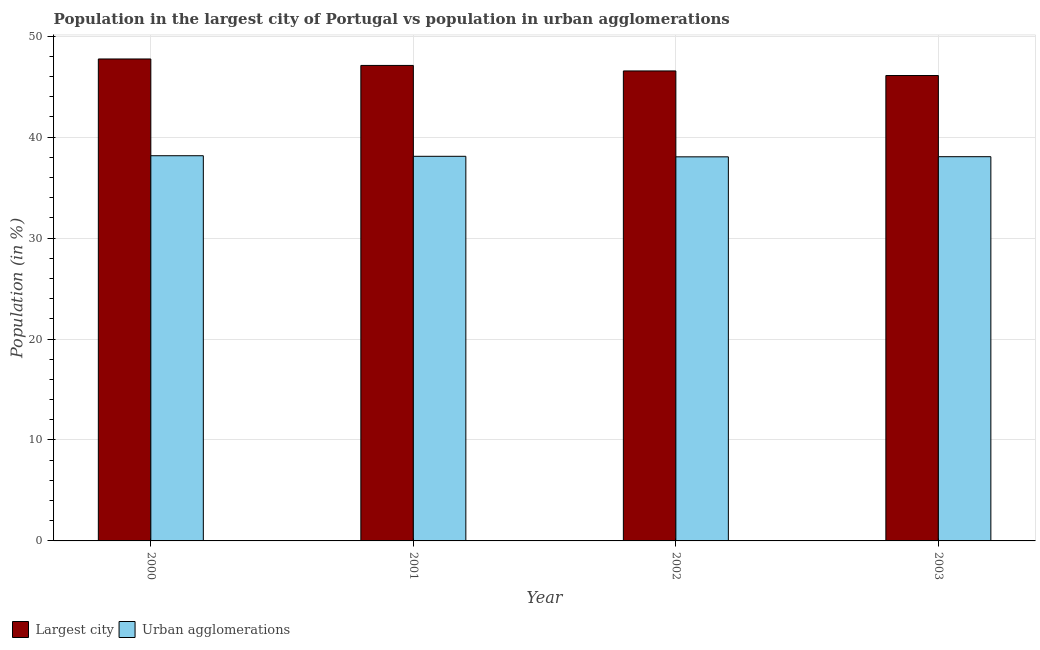How many groups of bars are there?
Ensure brevity in your answer.  4. Are the number of bars on each tick of the X-axis equal?
Keep it short and to the point. Yes. How many bars are there on the 4th tick from the left?
Offer a very short reply. 2. What is the population in urban agglomerations in 2000?
Provide a short and direct response. 38.16. Across all years, what is the maximum population in the largest city?
Ensure brevity in your answer.  47.74. Across all years, what is the minimum population in urban agglomerations?
Your response must be concise. 38.05. What is the total population in urban agglomerations in the graph?
Ensure brevity in your answer.  152.37. What is the difference between the population in the largest city in 2000 and that in 2002?
Offer a terse response. 1.19. What is the difference between the population in urban agglomerations in 2000 and the population in the largest city in 2002?
Make the answer very short. 0.11. What is the average population in urban agglomerations per year?
Make the answer very short. 38.09. What is the ratio of the population in the largest city in 2000 to that in 2002?
Your answer should be compact. 1.03. Is the population in the largest city in 2000 less than that in 2003?
Offer a terse response. No. Is the difference between the population in urban agglomerations in 2002 and 2003 greater than the difference between the population in the largest city in 2002 and 2003?
Give a very brief answer. No. What is the difference between the highest and the second highest population in the largest city?
Your answer should be compact. 0.64. What is the difference between the highest and the lowest population in the largest city?
Give a very brief answer. 1.64. In how many years, is the population in urban agglomerations greater than the average population in urban agglomerations taken over all years?
Your answer should be compact. 2. Is the sum of the population in urban agglomerations in 2000 and 2002 greater than the maximum population in the largest city across all years?
Provide a succinct answer. Yes. What does the 2nd bar from the left in 2000 represents?
Keep it short and to the point. Urban agglomerations. What does the 1st bar from the right in 2003 represents?
Provide a short and direct response. Urban agglomerations. Are all the bars in the graph horizontal?
Provide a succinct answer. No. Does the graph contain any zero values?
Offer a terse response. No. Does the graph contain grids?
Your answer should be compact. Yes. How many legend labels are there?
Provide a succinct answer. 2. What is the title of the graph?
Offer a terse response. Population in the largest city of Portugal vs population in urban agglomerations. Does "2012 US$" appear as one of the legend labels in the graph?
Provide a short and direct response. No. What is the label or title of the X-axis?
Make the answer very short. Year. What is the label or title of the Y-axis?
Make the answer very short. Population (in %). What is the Population (in %) of Largest city in 2000?
Offer a terse response. 47.74. What is the Population (in %) of Urban agglomerations in 2000?
Give a very brief answer. 38.16. What is the Population (in %) of Largest city in 2001?
Your answer should be very brief. 47.1. What is the Population (in %) of Urban agglomerations in 2001?
Give a very brief answer. 38.1. What is the Population (in %) of Largest city in 2002?
Your answer should be compact. 46.56. What is the Population (in %) of Urban agglomerations in 2002?
Your answer should be compact. 38.05. What is the Population (in %) of Largest city in 2003?
Give a very brief answer. 46.1. What is the Population (in %) in Urban agglomerations in 2003?
Keep it short and to the point. 38.06. Across all years, what is the maximum Population (in %) in Largest city?
Your answer should be very brief. 47.74. Across all years, what is the maximum Population (in %) in Urban agglomerations?
Give a very brief answer. 38.16. Across all years, what is the minimum Population (in %) of Largest city?
Your answer should be very brief. 46.1. Across all years, what is the minimum Population (in %) of Urban agglomerations?
Your answer should be very brief. 38.05. What is the total Population (in %) in Largest city in the graph?
Ensure brevity in your answer.  187.51. What is the total Population (in %) of Urban agglomerations in the graph?
Give a very brief answer. 152.37. What is the difference between the Population (in %) of Largest city in 2000 and that in 2001?
Give a very brief answer. 0.64. What is the difference between the Population (in %) in Urban agglomerations in 2000 and that in 2001?
Your response must be concise. 0.06. What is the difference between the Population (in %) in Largest city in 2000 and that in 2002?
Ensure brevity in your answer.  1.19. What is the difference between the Population (in %) in Urban agglomerations in 2000 and that in 2002?
Make the answer very short. 0.11. What is the difference between the Population (in %) in Largest city in 2000 and that in 2003?
Ensure brevity in your answer.  1.64. What is the difference between the Population (in %) in Urban agglomerations in 2000 and that in 2003?
Offer a terse response. 0.1. What is the difference between the Population (in %) of Largest city in 2001 and that in 2002?
Your answer should be very brief. 0.55. What is the difference between the Population (in %) of Urban agglomerations in 2001 and that in 2002?
Your answer should be compact. 0.05. What is the difference between the Population (in %) of Urban agglomerations in 2001 and that in 2003?
Offer a very short reply. 0.04. What is the difference between the Population (in %) in Largest city in 2002 and that in 2003?
Keep it short and to the point. 0.45. What is the difference between the Population (in %) in Urban agglomerations in 2002 and that in 2003?
Make the answer very short. -0.01. What is the difference between the Population (in %) in Largest city in 2000 and the Population (in %) in Urban agglomerations in 2001?
Provide a succinct answer. 9.64. What is the difference between the Population (in %) of Largest city in 2000 and the Population (in %) of Urban agglomerations in 2002?
Keep it short and to the point. 9.69. What is the difference between the Population (in %) in Largest city in 2000 and the Population (in %) in Urban agglomerations in 2003?
Provide a short and direct response. 9.68. What is the difference between the Population (in %) of Largest city in 2001 and the Population (in %) of Urban agglomerations in 2002?
Your answer should be very brief. 9.05. What is the difference between the Population (in %) of Largest city in 2001 and the Population (in %) of Urban agglomerations in 2003?
Offer a terse response. 9.04. What is the difference between the Population (in %) in Largest city in 2002 and the Population (in %) in Urban agglomerations in 2003?
Give a very brief answer. 8.5. What is the average Population (in %) of Largest city per year?
Ensure brevity in your answer.  46.88. What is the average Population (in %) in Urban agglomerations per year?
Provide a succinct answer. 38.09. In the year 2000, what is the difference between the Population (in %) in Largest city and Population (in %) in Urban agglomerations?
Offer a terse response. 9.59. In the year 2001, what is the difference between the Population (in %) of Largest city and Population (in %) of Urban agglomerations?
Make the answer very short. 9. In the year 2002, what is the difference between the Population (in %) of Largest city and Population (in %) of Urban agglomerations?
Your answer should be very brief. 8.51. In the year 2003, what is the difference between the Population (in %) in Largest city and Population (in %) in Urban agglomerations?
Provide a succinct answer. 8.04. What is the ratio of the Population (in %) of Largest city in 2000 to that in 2001?
Offer a very short reply. 1.01. What is the ratio of the Population (in %) of Urban agglomerations in 2000 to that in 2001?
Provide a short and direct response. 1. What is the ratio of the Population (in %) of Largest city in 2000 to that in 2002?
Your answer should be very brief. 1.03. What is the ratio of the Population (in %) of Largest city in 2000 to that in 2003?
Provide a short and direct response. 1.04. What is the ratio of the Population (in %) in Urban agglomerations in 2000 to that in 2003?
Ensure brevity in your answer.  1. What is the ratio of the Population (in %) in Largest city in 2001 to that in 2002?
Your answer should be very brief. 1.01. What is the ratio of the Population (in %) in Largest city in 2001 to that in 2003?
Keep it short and to the point. 1.02. What is the ratio of the Population (in %) in Urban agglomerations in 2001 to that in 2003?
Give a very brief answer. 1. What is the ratio of the Population (in %) in Largest city in 2002 to that in 2003?
Make the answer very short. 1.01. What is the ratio of the Population (in %) in Urban agglomerations in 2002 to that in 2003?
Provide a succinct answer. 1. What is the difference between the highest and the second highest Population (in %) of Largest city?
Provide a short and direct response. 0.64. What is the difference between the highest and the second highest Population (in %) of Urban agglomerations?
Give a very brief answer. 0.06. What is the difference between the highest and the lowest Population (in %) of Largest city?
Your answer should be compact. 1.64. What is the difference between the highest and the lowest Population (in %) of Urban agglomerations?
Offer a very short reply. 0.11. 